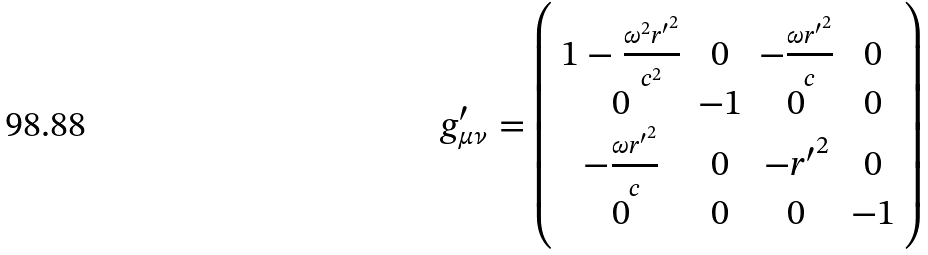<formula> <loc_0><loc_0><loc_500><loc_500>g _ { \mu \nu } ^ { \prime } = \left ( \begin{array} { c c c c } 1 - \frac { \omega ^ { 2 } { r ^ { \prime } } ^ { 2 } } { c ^ { 2 } } & 0 & - \frac { \omega { r ^ { \prime } } ^ { 2 } } { c } & 0 \\ 0 & - 1 & 0 & 0 \\ - \frac { \omega { r ^ { \prime } } ^ { 2 } } { c } & 0 & - { r ^ { \prime } } ^ { 2 } & 0 \\ 0 & 0 & 0 & - 1 \end{array} \right )</formula> 